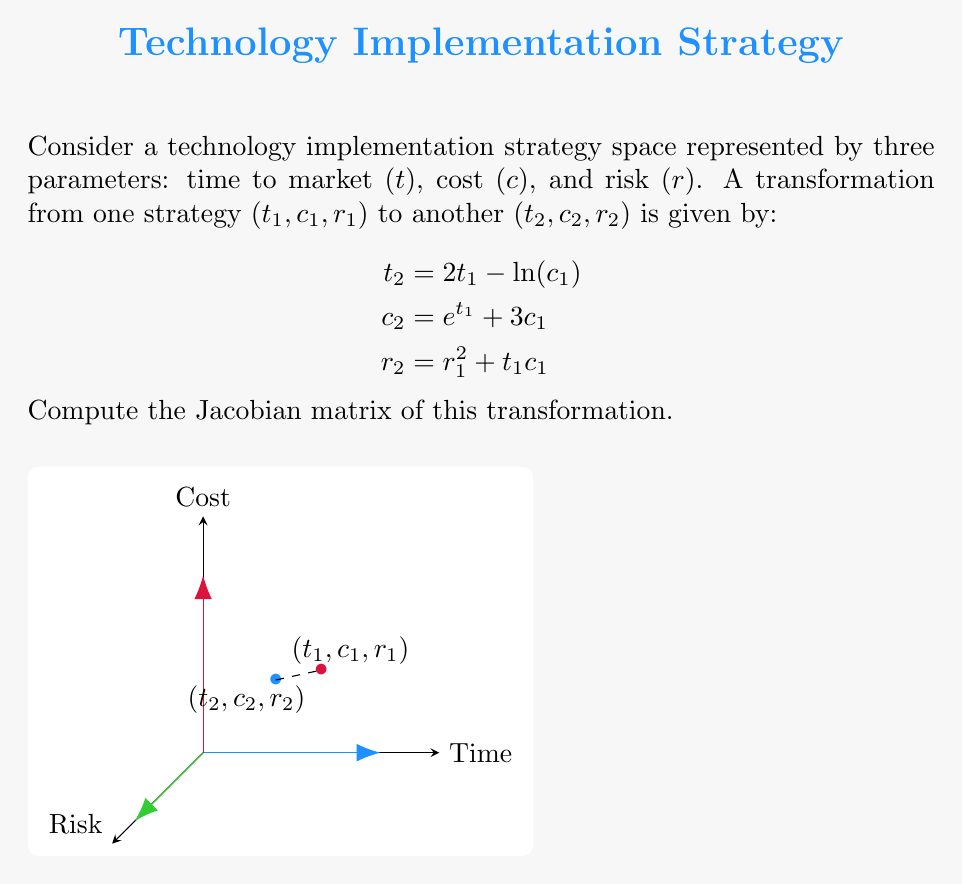Can you answer this question? To compute the Jacobian matrix, we need to find the partial derivatives of each output variable with respect to each input variable. The Jacobian matrix J is defined as:

$$J = \begin{bmatrix}
\frac{\partial t_2}{\partial t_1} & \frac{\partial t_2}{\partial c_1} & \frac{\partial t_2}{\partial r_1} \\
\frac{\partial c_2}{\partial t_1} & \frac{\partial c_2}{\partial c_1} & \frac{\partial c_2}{\partial r_1} \\
\frac{\partial r_2}{\partial t_1} & \frac{\partial r_2}{\partial c_1} & \frac{\partial r_2}{\partial r_1}
\end{bmatrix}$$

Let's compute each partial derivative:

1. $\frac{\partial t_2}{\partial t_1} = 2$
2. $\frac{\partial t_2}{\partial c_1} = -\frac{1}{c_1}$
3. $\frac{\partial t_2}{\partial r_1} = 0$

4. $\frac{\partial c_2}{\partial t_1} = e^{t_1}$
5. $\frac{\partial c_2}{\partial c_1} = 3$
6. $\frac{\partial c_2}{\partial r_1} = 0$

7. $\frac{\partial r_2}{\partial t_1} = c_1$
8. $\frac{\partial r_2}{\partial c_1} = t_1$
9. $\frac{\partial r_2}{\partial r_1} = 2r_1$

Now, we can construct the Jacobian matrix:

$$J = \begin{bmatrix}
2 & -\frac{1}{c_1} & 0 \\
e^{t_1} & 3 & 0 \\
c_1 & t_1 & 2r_1
\end{bmatrix}$$
Answer: $$J = \begin{bmatrix}
2 & -\frac{1}{c_1} & 0 \\
e^{t_1} & 3 & 0 \\
c_1 & t_1 & 2r_1
\end{bmatrix}$$ 